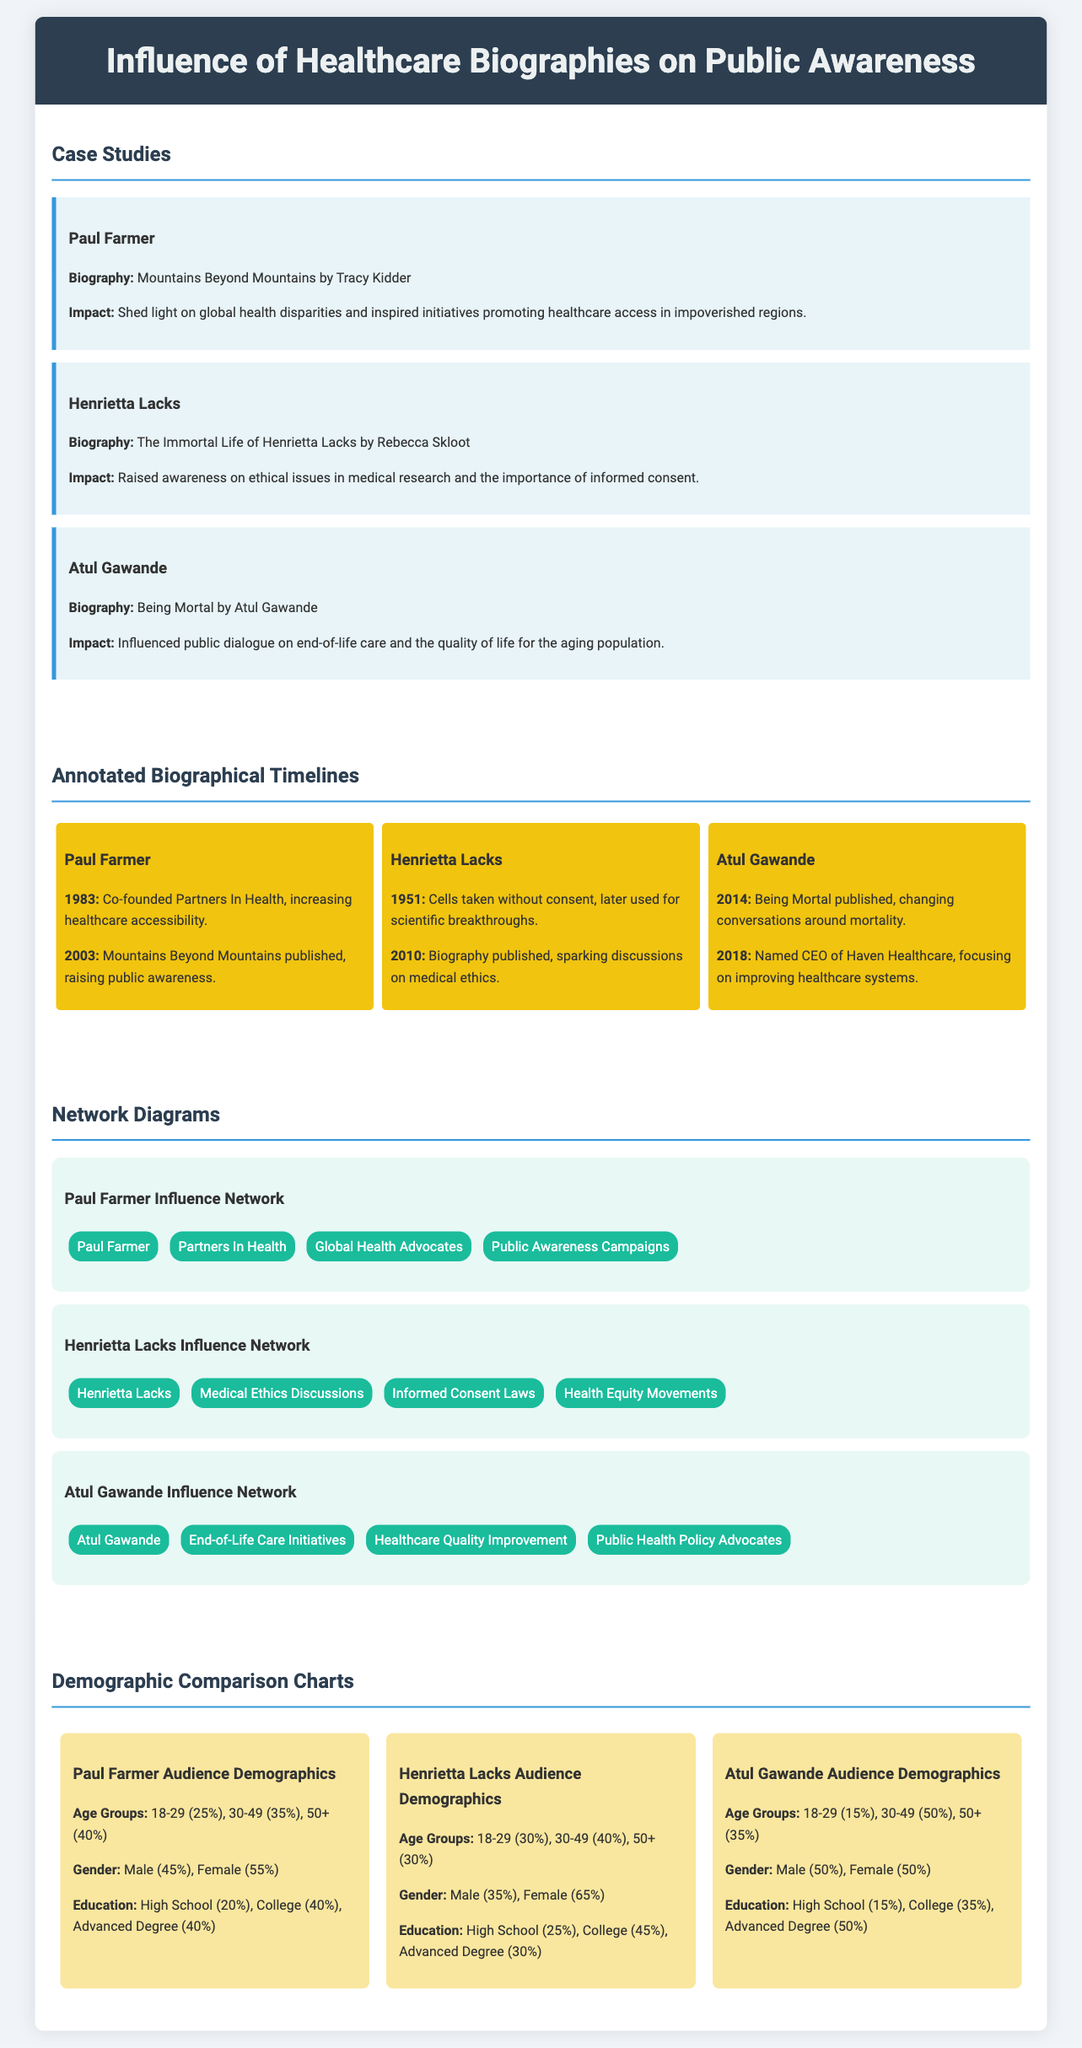What biography is associated with Paul Farmer? The biography associated with Paul Farmer is "Mountains Beyond Mountains" by Tracy Kidder.
Answer: "Mountains Beyond Mountains" What key issue did Henrietta Lacks' biography raise awareness about? Henrietta Lacks' biography raised awareness about ethical issues in medical research and the importance of informed consent.
Answer: Ethical issues in medical research When was "Being Mortal" published? "Being Mortal" was published in 2014.
Answer: 2014 What percentage of Paul Farmer's audience is aged 30-49? 35% of Paul Farmer's audience is aged 30-49.
Answer: 35% How many influential networks are listed for Atul Gawande? There are four influential networks listed for Atul Gawande.
Answer: Four Which case study biography emphasizes healthcare access in impoverished regions? The case study biography that emphasizes healthcare access in impoverished regions is about Paul Farmer.
Answer: Paul Farmer Who co-founded Partners In Health? Paul Farmer co-founded Partners In Health.
Answer: Paul Farmer What is the total percentage of Henrietta Lacks' audience with an advanced degree? The total percentage of Henrietta Lacks' audience with an advanced degree is 30%.
Answer: 30% What demographic group has equal gender representation in Atul Gawande's audience? The demographic group with equal gender representation in Atul Gawande's audience is Male and Female.
Answer: Male and Female 